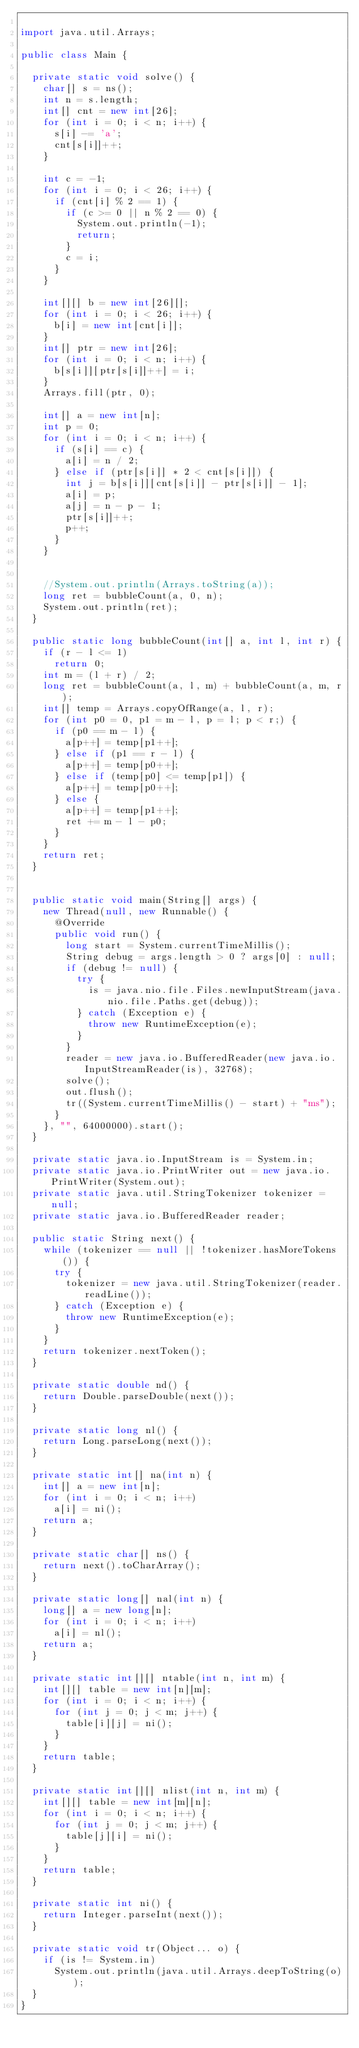<code> <loc_0><loc_0><loc_500><loc_500><_Java_>
import java.util.Arrays;

public class Main {

  private static void solve() {
    char[] s = ns();
    int n = s.length;
    int[] cnt = new int[26];
    for (int i = 0; i < n; i++) {
      s[i] -= 'a';
      cnt[s[i]]++;
    }

    int c = -1;
    for (int i = 0; i < 26; i++) {
      if (cnt[i] % 2 == 1) {
        if (c >= 0 || n % 2 == 0) {
          System.out.println(-1);
          return;
        }
        c = i;
      }
    }

    int[][] b = new int[26][];
    for (int i = 0; i < 26; i++) {
      b[i] = new int[cnt[i]];
    }
    int[] ptr = new int[26];
    for (int i = 0; i < n; i++) {
      b[s[i]][ptr[s[i]]++] = i;
    }
    Arrays.fill(ptr, 0);

    int[] a = new int[n];
    int p = 0;
    for (int i = 0; i < n; i++) {
      if (s[i] == c) {
        a[i] = n / 2;
      } else if (ptr[s[i]] * 2 < cnt[s[i]]) {
        int j = b[s[i]][cnt[s[i]] - ptr[s[i]] - 1];
        a[i] = p;
        a[j] = n - p - 1;
        ptr[s[i]]++;
        p++;
      }
    }


    //System.out.println(Arrays.toString(a));
    long ret = bubbleCount(a, 0, n);
    System.out.println(ret);
  }

  public static long bubbleCount(int[] a, int l, int r) {
    if (r - l <= 1)
      return 0;
    int m = (l + r) / 2;
    long ret = bubbleCount(a, l, m) + bubbleCount(a, m, r);
    int[] temp = Arrays.copyOfRange(a, l, r);
    for (int p0 = 0, p1 = m - l, p = l; p < r;) {
      if (p0 == m - l) {
        a[p++] = temp[p1++];
      } else if (p1 == r - l) {
        a[p++] = temp[p0++];
      } else if (temp[p0] <= temp[p1]) {
        a[p++] = temp[p0++];
      } else {
        a[p++] = temp[p1++];
        ret += m - l - p0;
      }
    }
    return ret;
  }


  public static void main(String[] args) {
    new Thread(null, new Runnable() {
      @Override
      public void run() {
        long start = System.currentTimeMillis();
        String debug = args.length > 0 ? args[0] : null;
        if (debug != null) {
          try {
            is = java.nio.file.Files.newInputStream(java.nio.file.Paths.get(debug));
          } catch (Exception e) {
            throw new RuntimeException(e);
          }
        }
        reader = new java.io.BufferedReader(new java.io.InputStreamReader(is), 32768);
        solve();
        out.flush();
        tr((System.currentTimeMillis() - start) + "ms");
      }
    }, "", 64000000).start();
  }

  private static java.io.InputStream is = System.in;
  private static java.io.PrintWriter out = new java.io.PrintWriter(System.out);
  private static java.util.StringTokenizer tokenizer = null;
  private static java.io.BufferedReader reader;

  public static String next() {
    while (tokenizer == null || !tokenizer.hasMoreTokens()) {
      try {
        tokenizer = new java.util.StringTokenizer(reader.readLine());
      } catch (Exception e) {
        throw new RuntimeException(e);
      }
    }
    return tokenizer.nextToken();
  }

  private static double nd() {
    return Double.parseDouble(next());
  }

  private static long nl() {
    return Long.parseLong(next());
  }

  private static int[] na(int n) {
    int[] a = new int[n];
    for (int i = 0; i < n; i++)
      a[i] = ni();
    return a;
  }

  private static char[] ns() {
    return next().toCharArray();
  }

  private static long[] nal(int n) {
    long[] a = new long[n];
    for (int i = 0; i < n; i++)
      a[i] = nl();
    return a;
  }

  private static int[][] ntable(int n, int m) {
    int[][] table = new int[n][m];
    for (int i = 0; i < n; i++) {
      for (int j = 0; j < m; j++) {
        table[i][j] = ni();
      }
    }
    return table;
  }

  private static int[][] nlist(int n, int m) {
    int[][] table = new int[m][n];
    for (int i = 0; i < n; i++) {
      for (int j = 0; j < m; j++) {
        table[j][i] = ni();
      }
    }
    return table;
  }

  private static int ni() {
    return Integer.parseInt(next());
  }

  private static void tr(Object... o) {
    if (is != System.in)
      System.out.println(java.util.Arrays.deepToString(o));
  }
}

</code> 